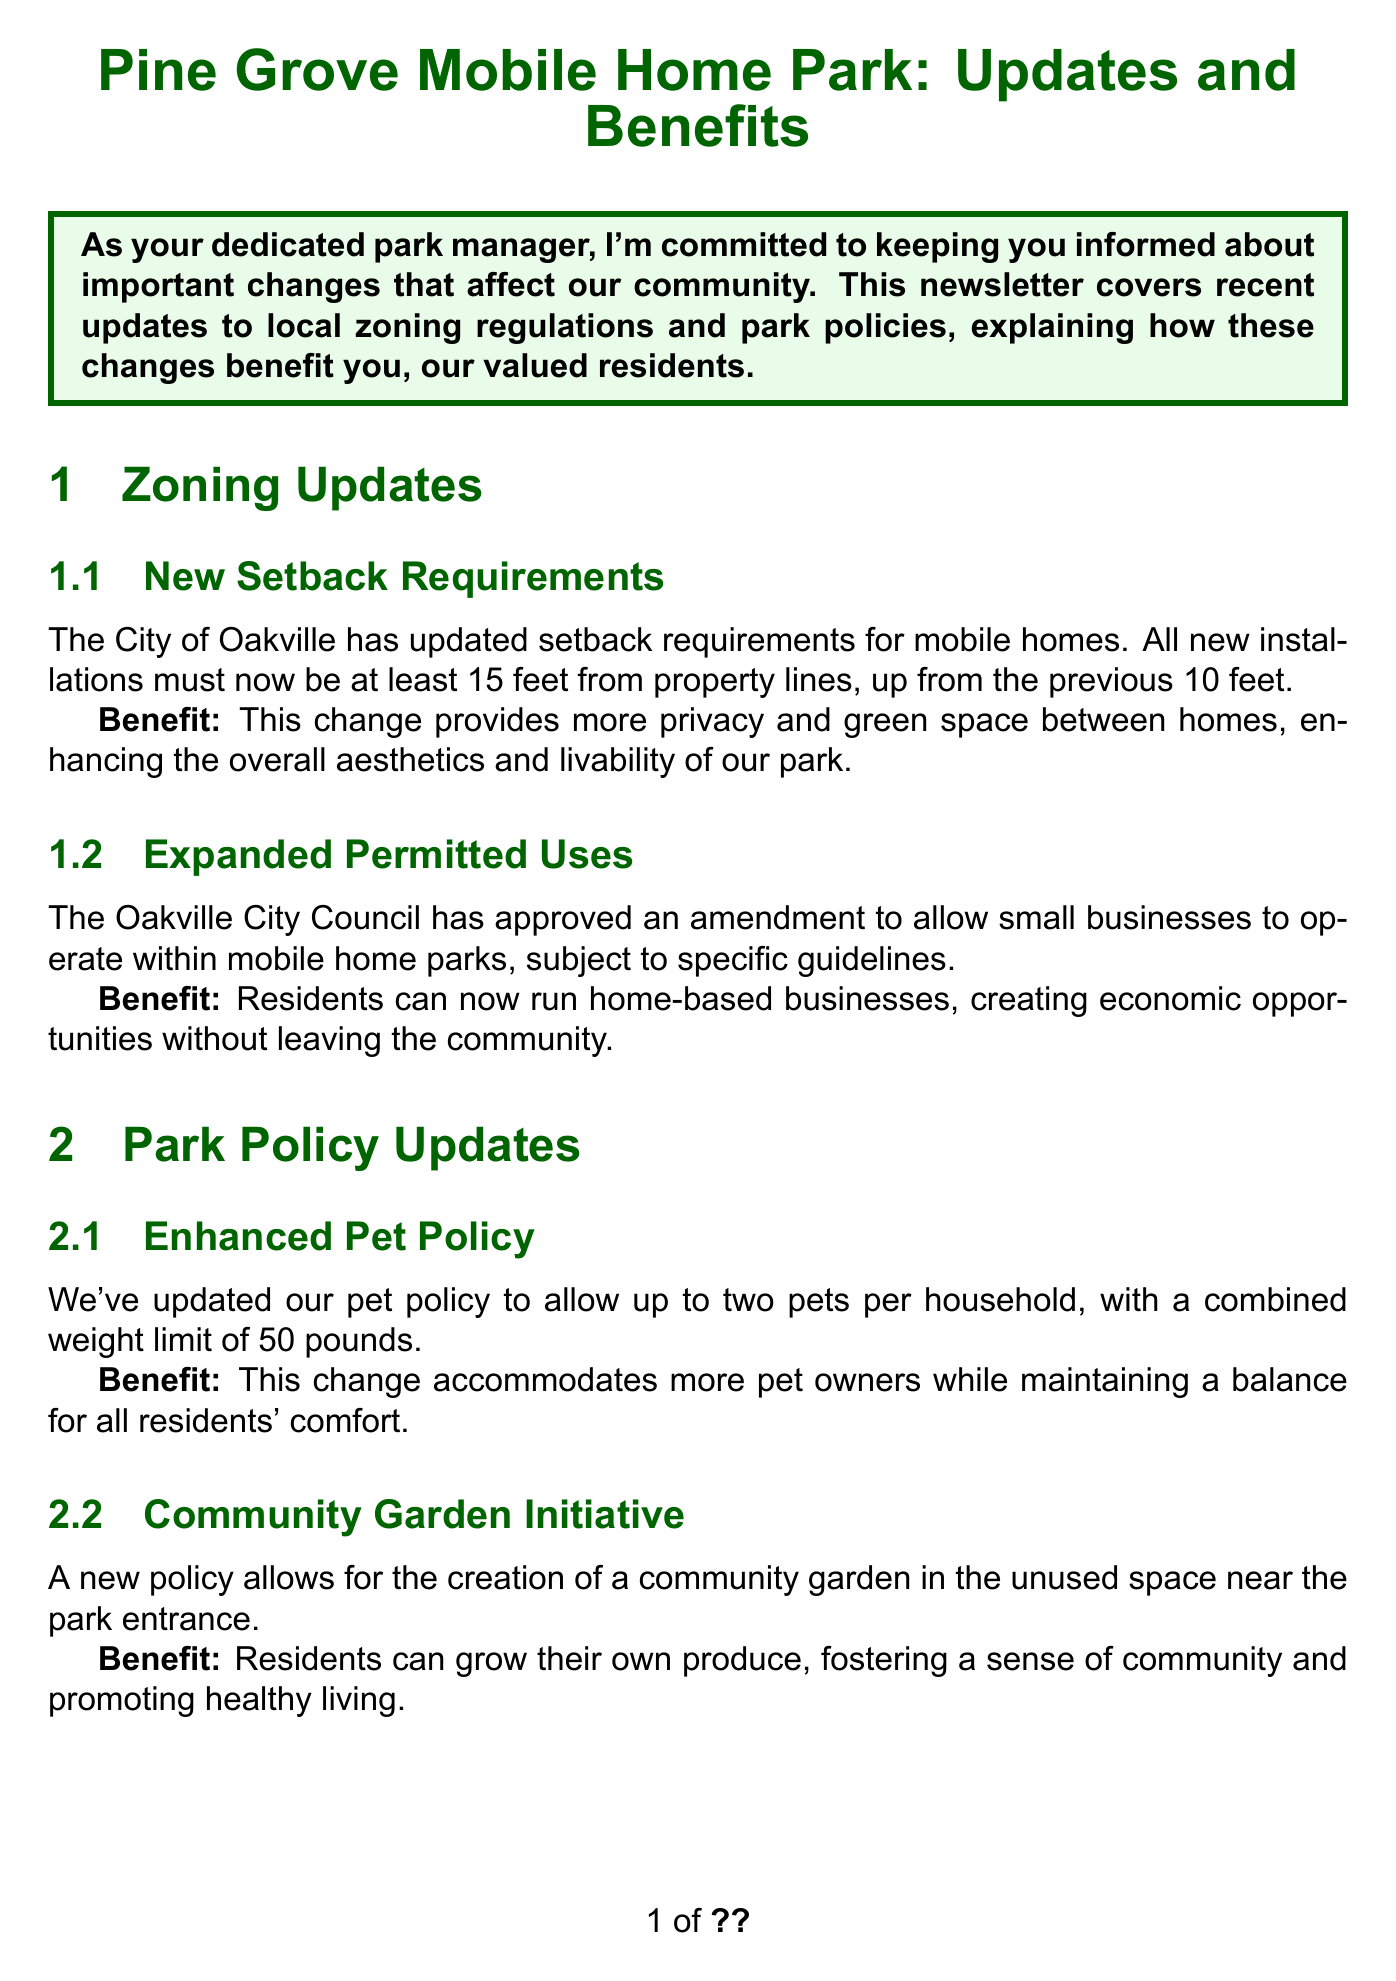What are the new setback requirements? The new setback requirements are defined as the distance mobile homes must be placed from property lines, which has increased from 10 feet to 15 feet.
Answer: 15 feet What is the benefit of the new setback requirements? The benefit is that it provides more privacy and green space between homes, enhancing aesthetics and livability.
Answer: More privacy and green space What amendment has the Oakville City Council approved? The amendment allows small businesses to operate within mobile home parks, following specific guidelines.
Answer: Small businesses What is the combined weight limit for pets under the new pet policy? The combined weight limit for pets allowed per household under the enhanced pet policy is specified.
Answer: 50 pounds What is the purpose of the community garden initiative? The community garden initiative allows residents to grow their own produce, fostering community and promoting healthy living.
Answer: Grow their own produce When is the Community Garden Kick-off event scheduled? The day and month of the event where residents can participate in planting the community garden seeds have been noted.
Answer: July 1, 2023 Who provided a testimonial about the new setback requirements? The document includes the name of a resident who shared positive feedback regarding the changes in setback requirements and the community garden.
Answer: Sarah Johnson What is one feature of the improved maintenance request system? The document details a specific improvement in service features regarding maintenance requests that residents can utilize anytime.
Answer: Online maintenance request portal What overall commitment does the Pine Grove Mobile Home Park emphasize in the conclusion? The conclusion summarizes the park's dedication to enhancing resident living experiences through compliance with regulations and community efforts.
Answer: Thriving community 